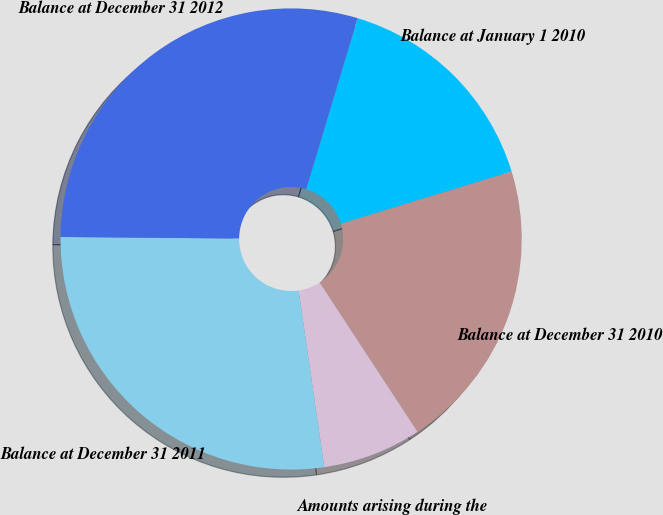Convert chart to OTSL. <chart><loc_0><loc_0><loc_500><loc_500><pie_chart><fcel>Balance at January 1 2010<fcel>Balance at December 31 2010<fcel>Amounts arising during the<fcel>Balance at December 31 2011<fcel>Balance at December 31 2012<nl><fcel>15.62%<fcel>20.49%<fcel>6.94%<fcel>27.43%<fcel>29.51%<nl></chart> 